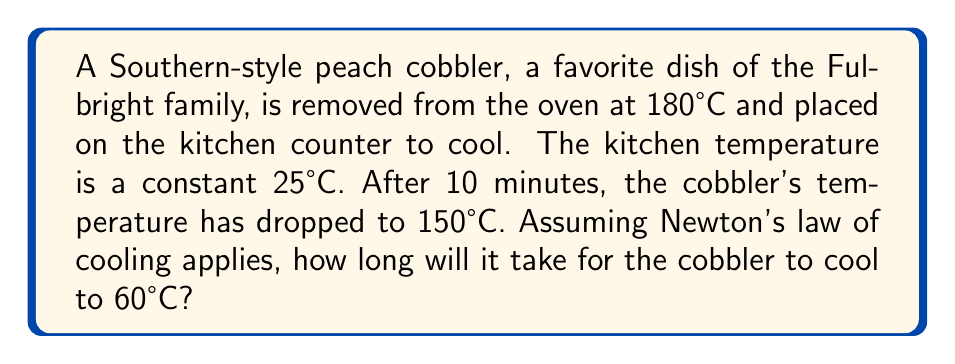Could you help me with this problem? Let's approach this step-by-step using Newton's law of cooling:

1) Newton's law of cooling states that the rate of change of the temperature of an object is proportional to the difference between its temperature and the ambient temperature. Mathematically:

   $$\frac{dT}{dt} = -k(T - T_a)$$

   where $T$ is the object's temperature, $T_a$ is the ambient temperature, $t$ is time, and $k$ is the cooling constant.

2) The solution to this differential equation is:

   $$T(t) = T_a + (T_0 - T_a)e^{-kt}$$

   where $T_0$ is the initial temperature.

3) We need to find $k$ using the given information:
   $T_0 = 180°C$, $T_a = 25°C$, $T(10) = 150°C$

4) Substituting into the equation:

   $$150 = 25 + (180 - 25)e^{-10k}$$

5) Solving for $k$:

   $$125 = 155e^{-10k}$$
   $$\frac{125}{155} = e^{-10k}$$
   $$\ln(\frac{125}{155}) = -10k$$
   $$k = -\frac{1}{10}\ln(\frac{125}{155}) \approx 0.0215 \text{ min}^{-1}$$

6) Now we can use this $k$ to find the time $t$ when $T(t) = 60°C$:

   $$60 = 25 + (180 - 25)e^{-0.0215t}$$

7) Solving for $t$:

   $$35 = 155e^{-0.0215t}$$
   $$\frac{35}{155} = e^{-0.0215t}$$
   $$\ln(\frac{35}{155}) = -0.0215t$$
   $$t = -\frac{1}{0.0215}\ln(\frac{35}{155}) \approx 71.8 \text{ minutes}$$
Answer: 71.8 minutes 